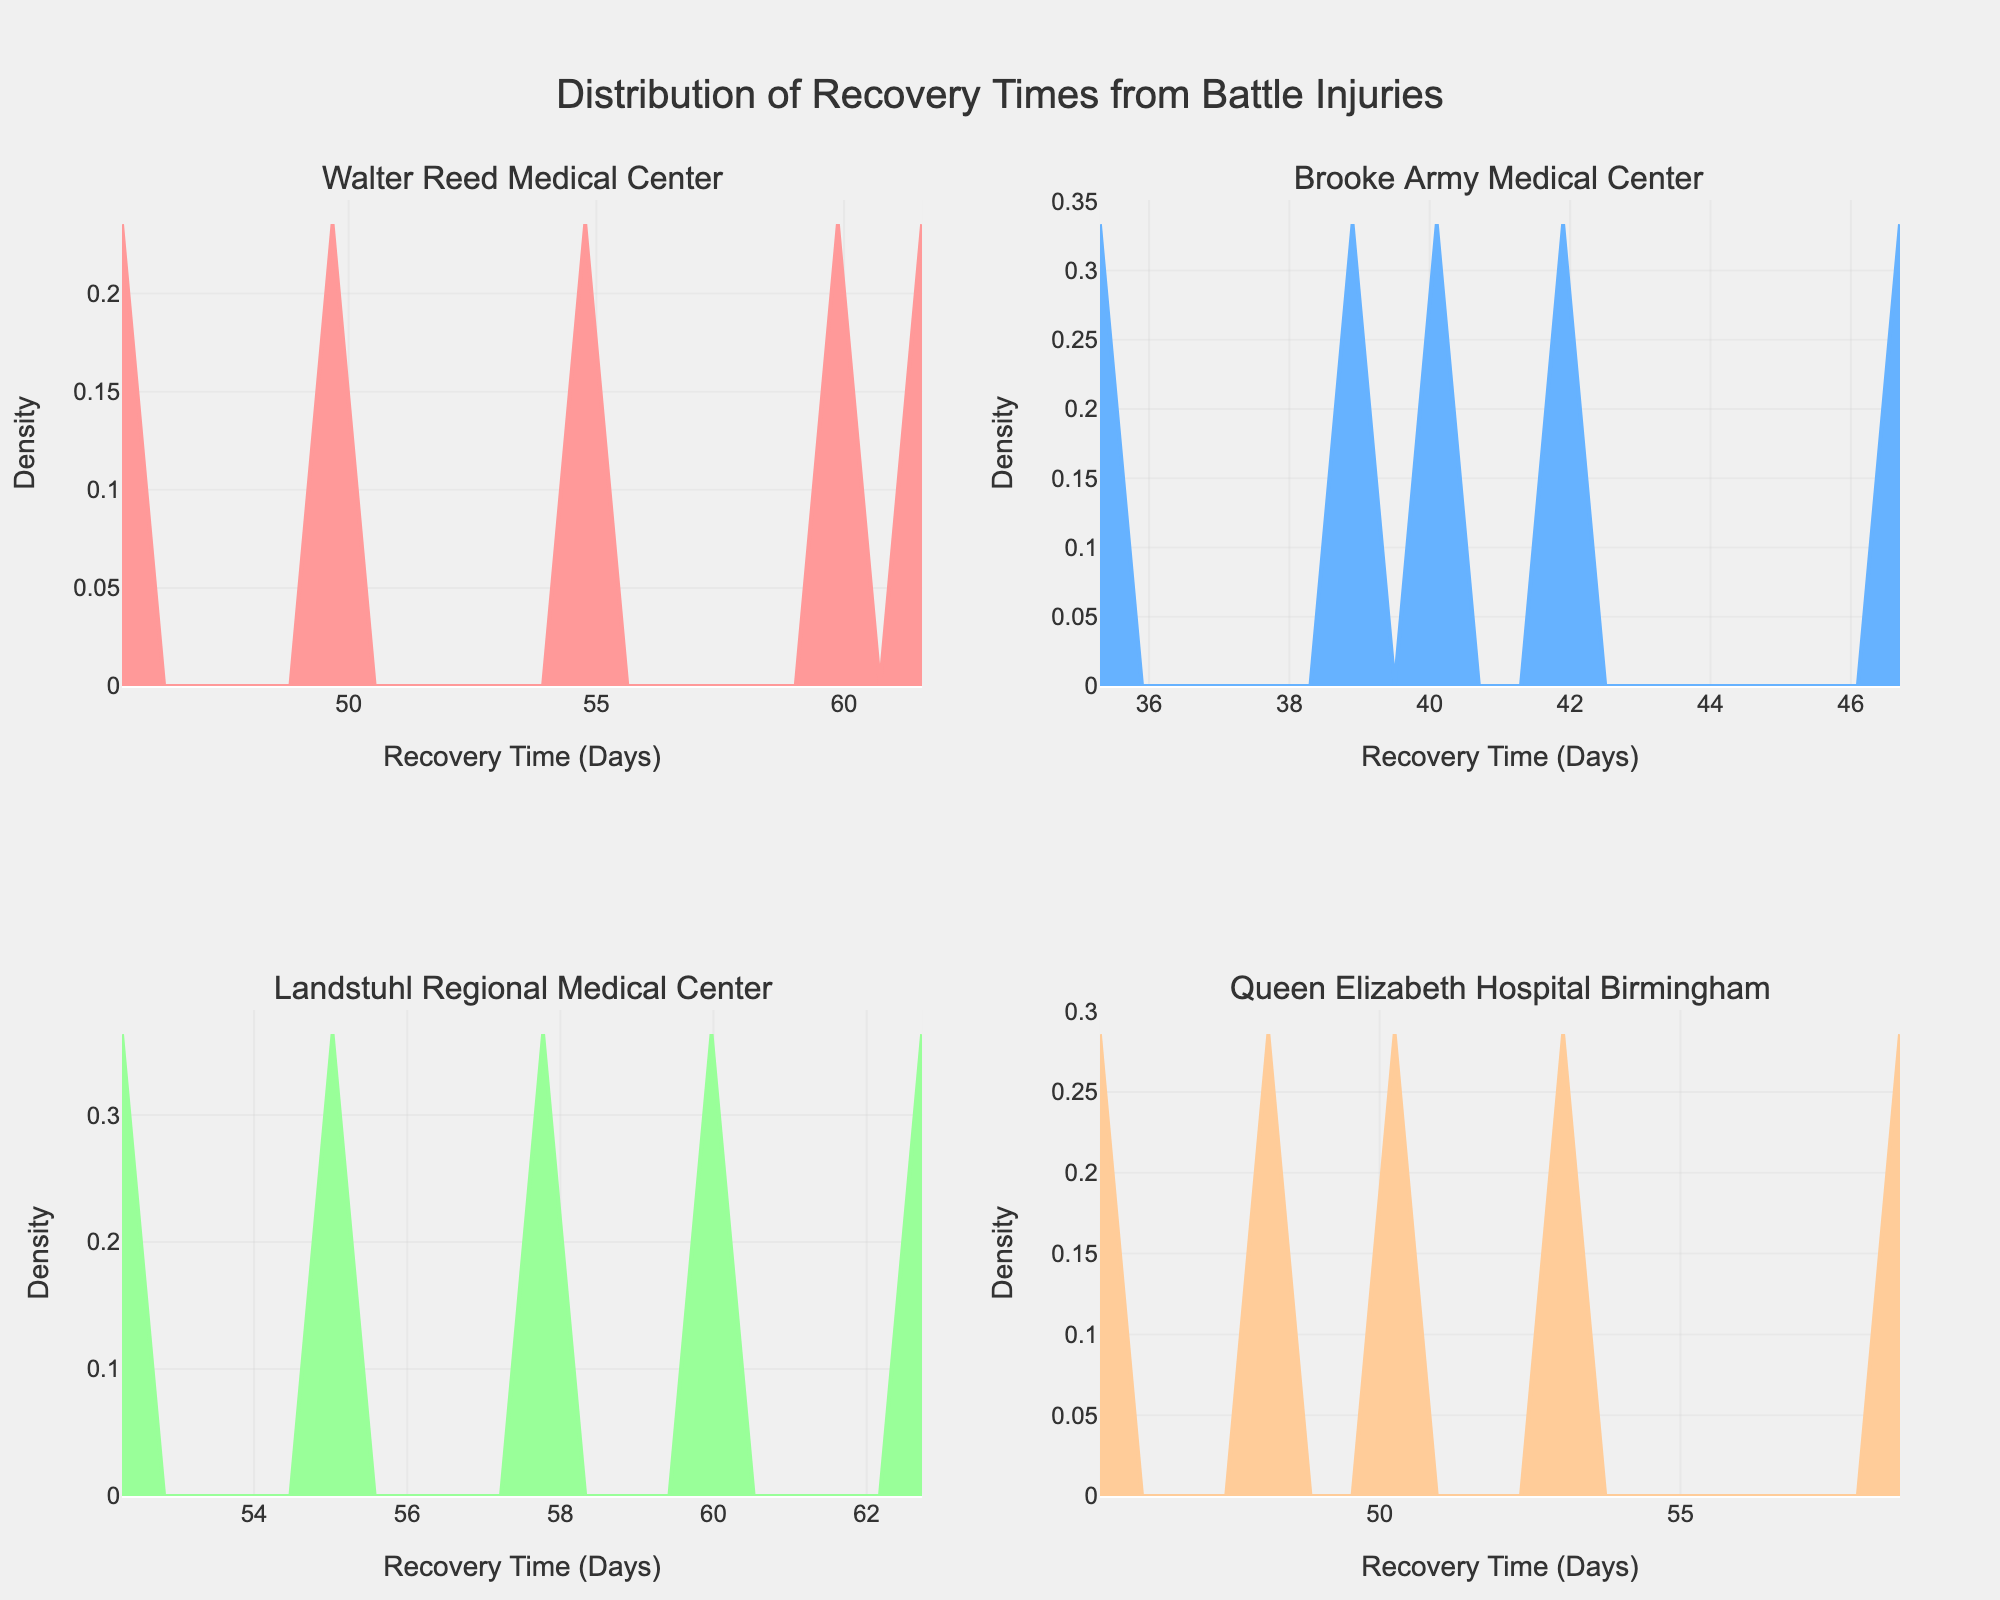What is the title of the figure? The title is the text at the top of the figure that describes what the plot is about.
Answer: Distribution of Recovery Times from Battle Injuries How many medical facilities are compared in the figure? Each subplot represents a different medical facility, and there are four subplots in total.
Answer: Four Which facility has the peak density at the shortest recovery time? The peak density refers to the highest point in the density plot, indicative of the most common recovery time. By visually comparing the heights and positions of peaks, we see that Brooke Army Medical Center has the peak at the shortest recovery time.
Answer: Brooke Army Medical Center How does the range of recovery times at Walter Reed Medical Center compare to the range at Queen Elizabeth Hospital Birmingham? To answer this, observe the spread of the density plots along the x-axis for each facility. Walter Reed Medical Center has a range of recovery times from around 45 to 62 days, while Queen Elizabeth Hospital Birmingham has a range from around 45 to 59 days.
Answer: Walter Reed Medical Center has a wider range Which facility has the lowest recovery time's peak density, indicating a possibly faster average recovery? The facility with the lowest peak density suggesting a higher concentration of shorter recovery times is Brooke Army Medical Center, peaking closer to 35-40 days.
Answer: Brooke Army Medical Center What is the main difference between the recovery time distributions of Walter Reed Medical Center and Landstuhl Regional Medical Center? By observing the density plots, Walter Reed Medical Center has a broader distribution of recovery times, whereas Landstuhl Regional Medical Center has a more concentrated peak around 60 days, indicating a more uniform recovery time.
Answer: Walter Reed Medical Center has a broader distribution; Landstuhl Regional Medical Center is more concentrated Which subplot shows a distribution that indicates the highest uniformity in recovery times? The most uniform distribution would have the narrowest and highest peak, indicating that most recovery times are similar. This is typically seen at Landstuhl Regional Medical Center.
Answer: Landstuhl Regional Medical Center Between Queen Elizabeth Hospital Birmingham and Brooke Army Medical Center, which facility tends to have shorter recovery times? To determine this, observe the central tendency of the density plots. Brooke Army Medical Center has recovery times mainly between 35-47 days, while Queen Elizabeth Hospital Birmingham has recovery times mainly between 45-59 days. Thus, Brooke Army Medical Center tends to have shorter recovery times.
Answer: Brooke Army Medical Center 